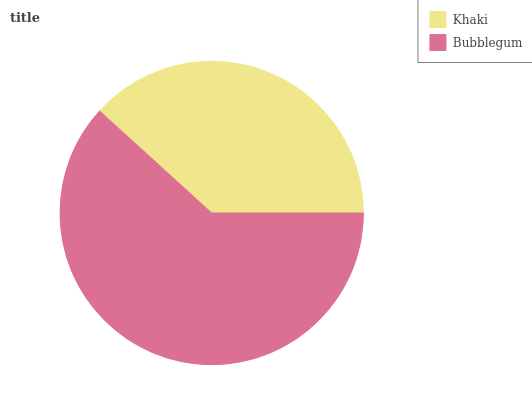Is Khaki the minimum?
Answer yes or no. Yes. Is Bubblegum the maximum?
Answer yes or no. Yes. Is Bubblegum the minimum?
Answer yes or no. No. Is Bubblegum greater than Khaki?
Answer yes or no. Yes. Is Khaki less than Bubblegum?
Answer yes or no. Yes. Is Khaki greater than Bubblegum?
Answer yes or no. No. Is Bubblegum less than Khaki?
Answer yes or no. No. Is Bubblegum the high median?
Answer yes or no. Yes. Is Khaki the low median?
Answer yes or no. Yes. Is Khaki the high median?
Answer yes or no. No. Is Bubblegum the low median?
Answer yes or no. No. 